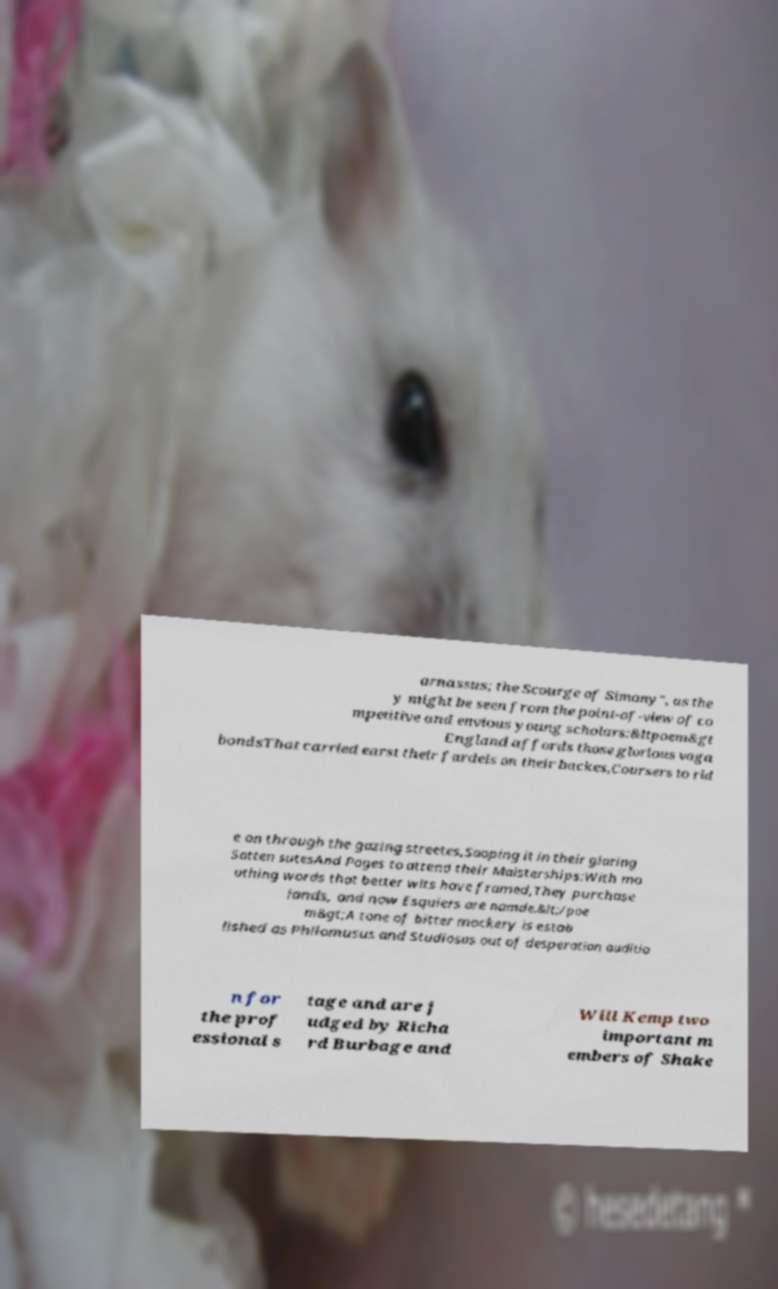Please identify and transcribe the text found in this image. arnassus; the Scourge of Simony", as the y might be seen from the point-of-view of co mpetitive and envious young scholars:&ltpoem&gt England affords those glorious vaga bondsThat carried earst their fardels on their backes,Coursers to rid e on through the gazing streetes,Sooping it in their glaring Satten sutesAnd Pages to attend their Maisterships:With mo uthing words that better wits have framed,They purchase lands, and now Esquiers are namde.&lt;/poe m&gt;A tone of bitter mockery is estab lished as Philomusus and Studiosus out of desperation auditio n for the prof essional s tage and are j udged by Richa rd Burbage and Will Kemp two important m embers of Shake 